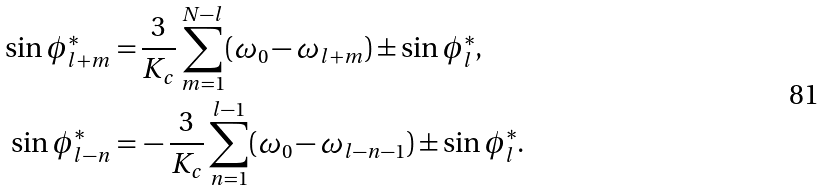<formula> <loc_0><loc_0><loc_500><loc_500>\sin \phi _ { l + m } ^ { * } = & \, \frac { 3 } { K _ { c } } \sum _ { m = 1 } ^ { N - l } ( \omega _ { 0 } - \omega _ { l + m } ) \pm \sin \phi _ { l } ^ { * } , \\ \sin \phi _ { l - n } ^ { * } = & \, - \frac { 3 } { K _ { c } } \sum _ { n = 1 } ^ { l - 1 } ( \omega _ { 0 } - \omega _ { l - n - 1 } ) \pm \sin \phi _ { l } ^ { * } .</formula> 